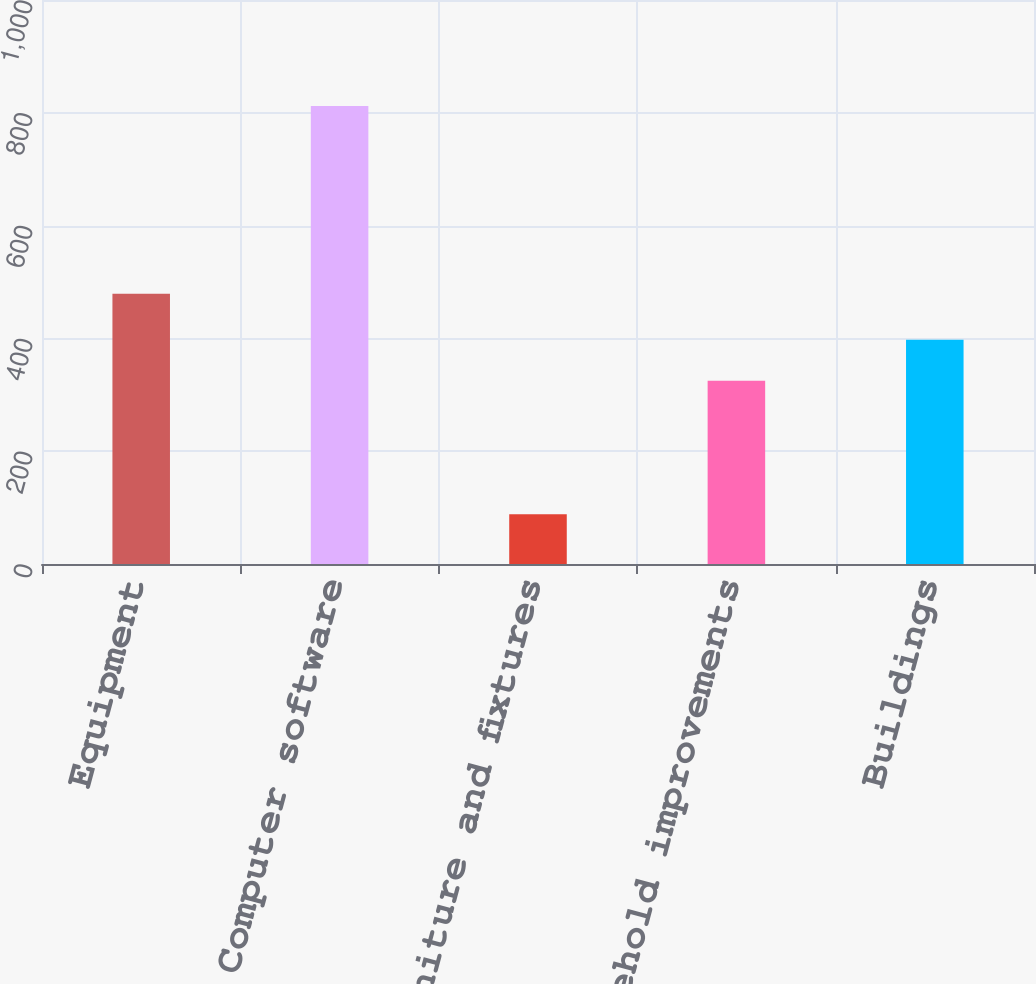<chart> <loc_0><loc_0><loc_500><loc_500><bar_chart><fcel>Equipment<fcel>Computer software<fcel>Furniture and fixtures<fcel>Leasehold improvements<fcel>Buildings<nl><fcel>479<fcel>812<fcel>88<fcel>325<fcel>397.4<nl></chart> 